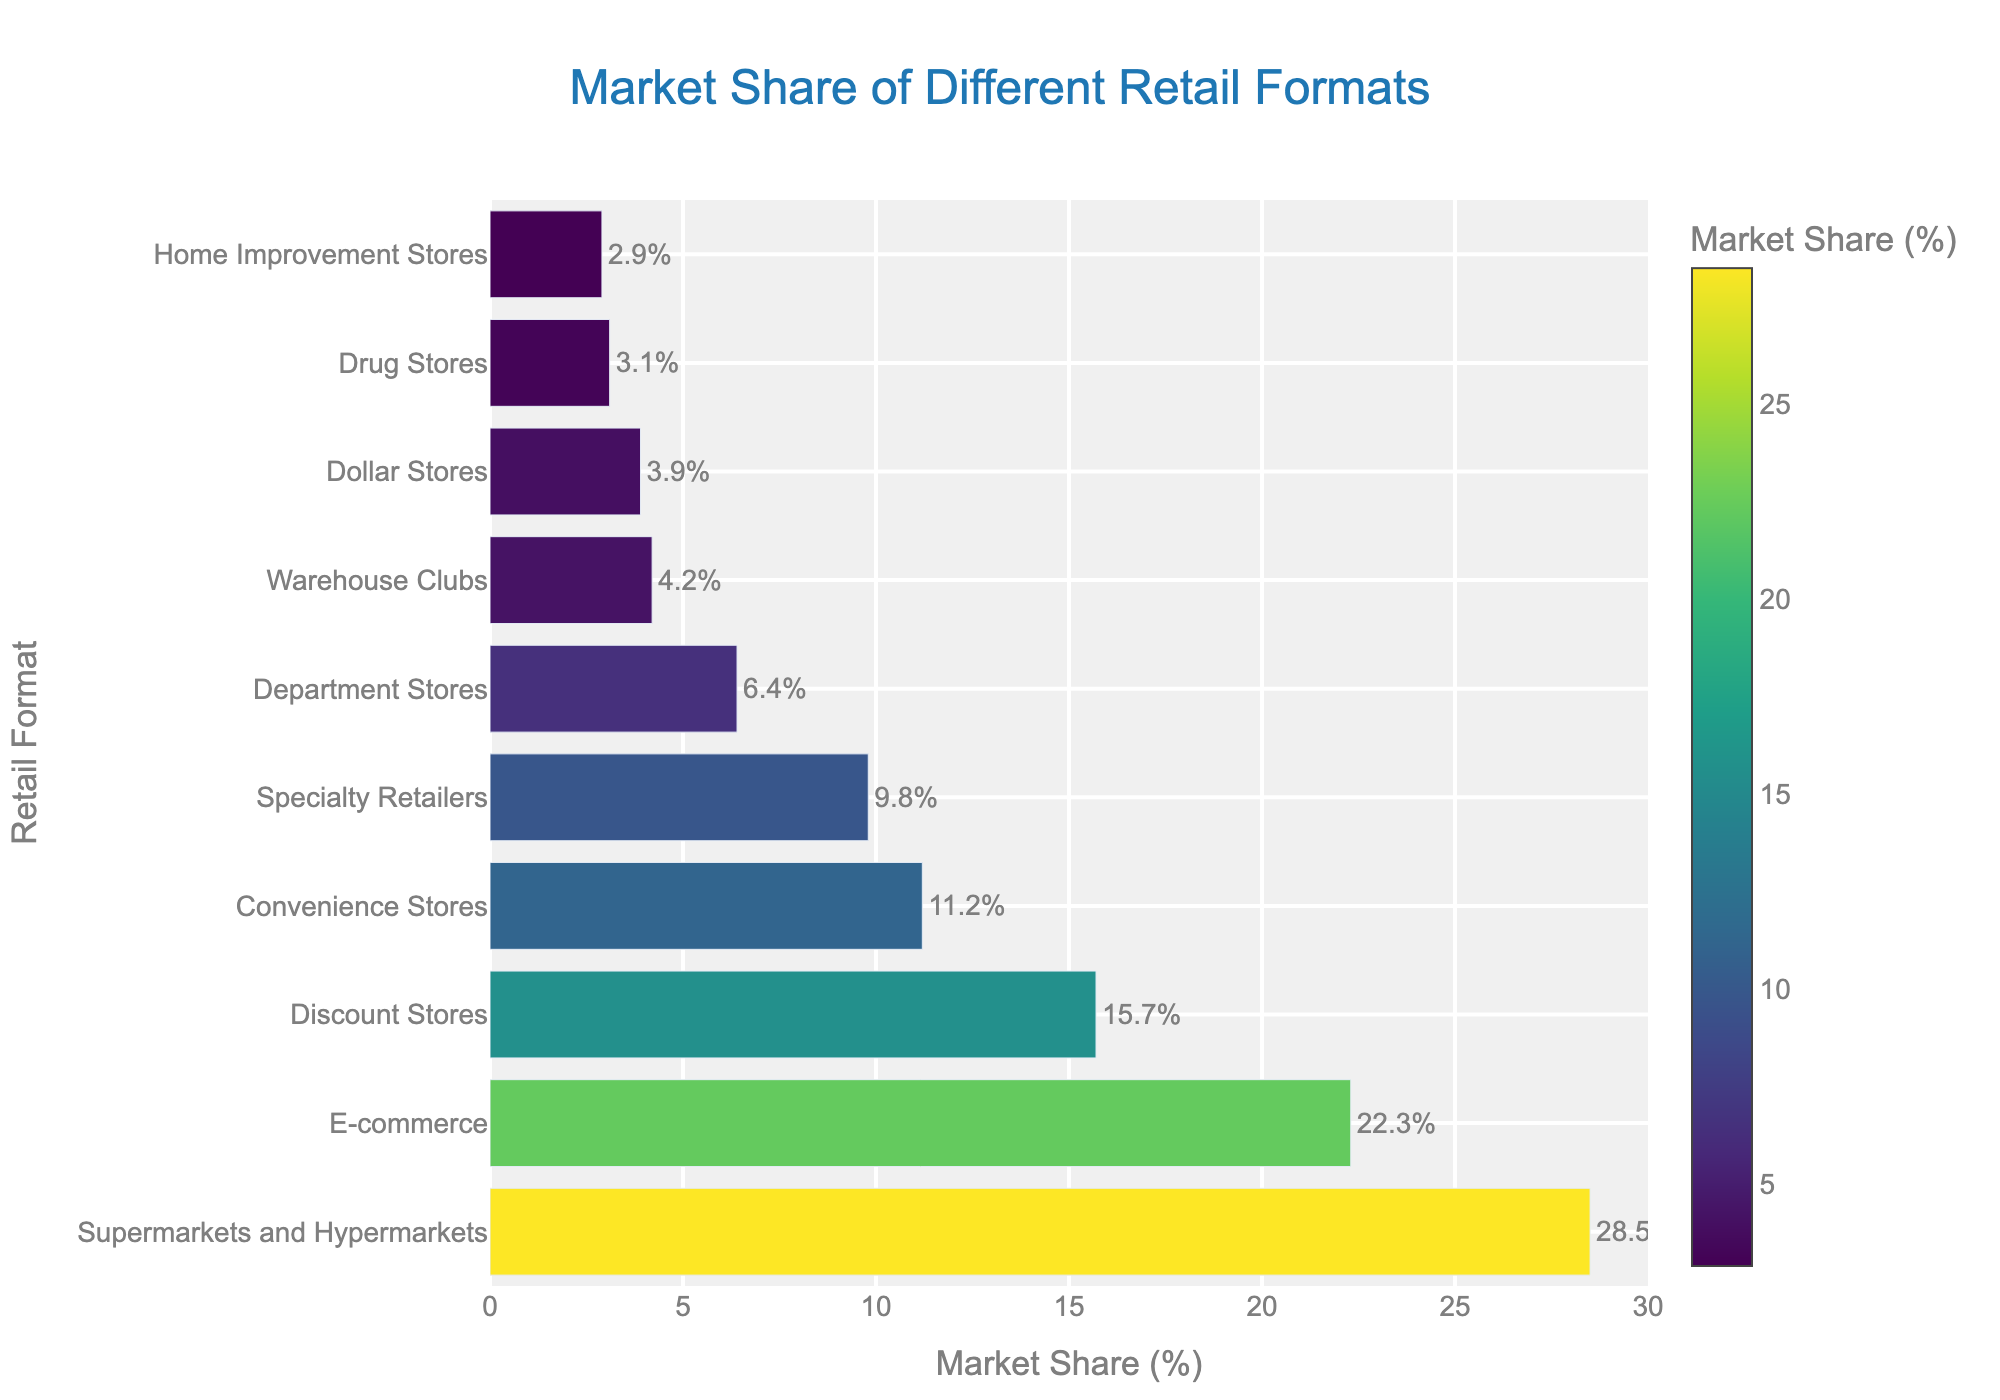What is the retail format with the highest market share? The bar chart shows different retail formats along the y-axis and their respective market shares along the x-axis. The longest bar represents the retail format with the highest share. The longest bar is for 'Supermarkets and Hypermarkets' with a market share of 28.5%.
Answer: Supermarkets and Hypermarkets Which retail format has a lower market share: Discount Stores or Department Stores? To find the answer, compare the length and position of the bars for 'Discount Stores' and 'Department Stores'. Discount Stores have a market share of 15.7%, while Department Stores have a market share of 6.4%.
Answer: Department Stores How much higher is the market share of E-commerce compared to Convenience Stores? Identify the market share values for E-commerce (22.3%) and Convenience Stores (11.2%). Subtract the smaller value from the larger value: 22.3% - 11.2% = 11.1%.
Answer: 11.1% What is the combined market share of Specialty Retailers and Warehouse Clubs? Find the market share for both Specialty Retailers (9.8%) and Warehouse Clubs (4.2%). Add the two values: 9.8% + 4.2% = 14.0%.
Answer: 14.0% Which retail formats have a market share greater than 10%? Check the bars and their corresponding market share values. Retail formats with market shares greater than 10% are 'Supermarkets and Hypermarkets' with 28.5%, 'E-commerce' with 22.3%, 'Discount Stores' with 15.7%, and 'Convenience Stores' with 11.2%.
Answer: Supermarkets and Hypermarkets, E-commerce, Discount Stores, Convenience Stores What is the difference in market share between the largest and the smallest retail formats? Identify the market share of the largest format (Supermarkets and Hypermarkets: 28.5%) and the smallest format (Home Improvement Stores: 2.9%). Subtract the smallest value from the largest: 28.5% - 2.9% = 25.6%.
Answer: 25.6% Which retail format has a market share of 3.9%? Locate the bar with a market share of 3.9%. The corresponding retail format is 'Dollar Stores'.
Answer: Dollar Stores Sum the market shares of Drug Stores and Home Improvement Stores. Are they higher than the market share of Convenience Stores? Find the market share values for Drug Stores (3.1%) and Home Improvement Stores (2.9%). Add them up: 3.1% + 2.9% = 6.0%. Compare this with the market share of Convenience Stores (11.2%). Since 6.0% is less than 11.2%, the answer is no.
Answer: No What is the average market share of the top three retail formats? Identify the market share of the top three formats: Supermarkets and Hypermarkets (28.5%), E-commerce (22.3%), and Discount Stores (15.7%). Calculate the average: (28.5% + 22.3% + 15.7%) / 3 = 66.5% / 3 = 22.17%.
Answer: 22.17% Which retail format is represented by the darkest bar color and what is its market share? The color scale in the bar chart indicates that the darkest color corresponds to the highest market share. The darkest bar is for 'Supermarkets and Hypermarkets' with a market share of 28.5%.
Answer: Supermarkets and Hypermarkets, 28.5% 